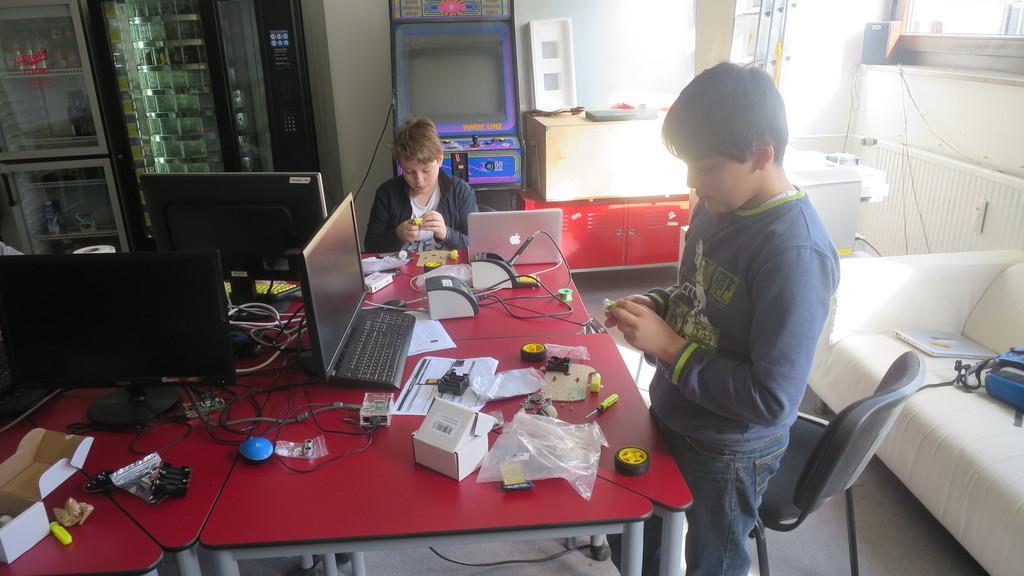Can you describe this image briefly? In this picture we can see two boys one is standing and other is sitting and in front of them we can see table and on table we have boxes, wires, laptop, paper, cover, wheel, screw driver, device beside to them we have sofa, cupboards, wall. 